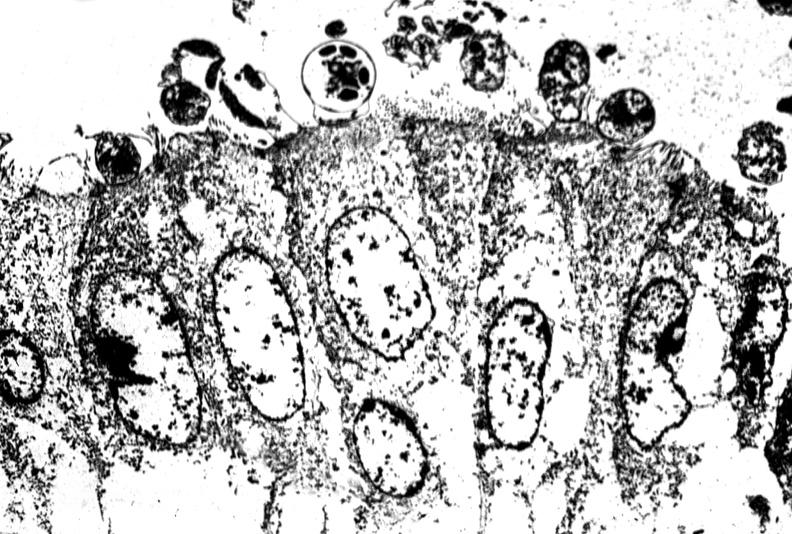where is this electron microscopy figure taken?
Answer the question using a single word or phrase. Gastrointestinal system 